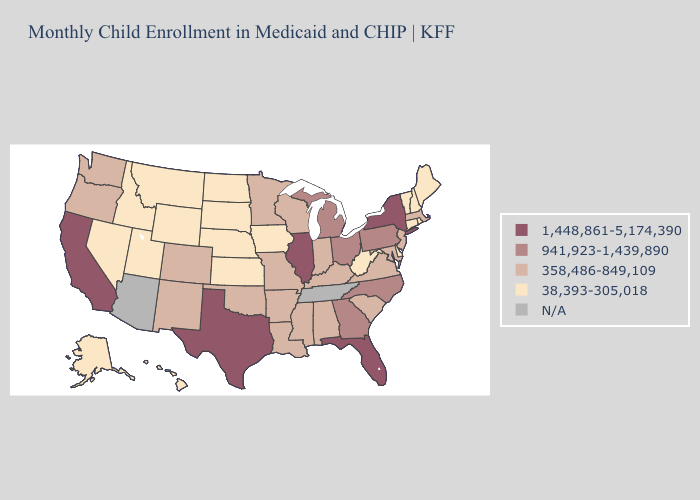How many symbols are there in the legend?
Be succinct. 5. What is the lowest value in the MidWest?
Be succinct. 38,393-305,018. What is the highest value in the USA?
Quick response, please. 1,448,861-5,174,390. Among the states that border Tennessee , does Virginia have the highest value?
Give a very brief answer. No. Name the states that have a value in the range 1,448,861-5,174,390?
Keep it brief. California, Florida, Illinois, New York, Texas. Is the legend a continuous bar?
Be succinct. No. Does Wyoming have the lowest value in the USA?
Concise answer only. Yes. What is the value of Wyoming?
Be succinct. 38,393-305,018. Which states have the highest value in the USA?
Give a very brief answer. California, Florida, Illinois, New York, Texas. What is the highest value in the USA?
Concise answer only. 1,448,861-5,174,390. Name the states that have a value in the range 38,393-305,018?
Be succinct. Alaska, Connecticut, Delaware, Hawaii, Idaho, Iowa, Kansas, Maine, Montana, Nebraska, Nevada, New Hampshire, North Dakota, Rhode Island, South Dakota, Utah, Vermont, West Virginia, Wyoming. Does Delaware have the highest value in the USA?
Write a very short answer. No. Among the states that border Connecticut , does Rhode Island have the highest value?
Short answer required. No. 